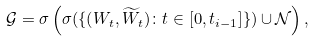Convert formula to latex. <formula><loc_0><loc_0><loc_500><loc_500>\mathcal { G } = \sigma \left ( \sigma ( \{ ( W _ { t } , \widetilde { W } _ { t } ) \colon t \in [ 0 , t _ { i - 1 } ] \} ) \cup \mathcal { N } \right ) ,</formula> 